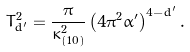<formula> <loc_0><loc_0><loc_500><loc_500>T _ { d ^ { \prime } } ^ { 2 } = \frac { \pi } { \kappa _ { \left ( 1 0 \right ) } ^ { 2 } } \left ( 4 \pi ^ { 2 } \alpha ^ { \prime } \right ) ^ { 4 - d ^ { \prime } } .</formula> 